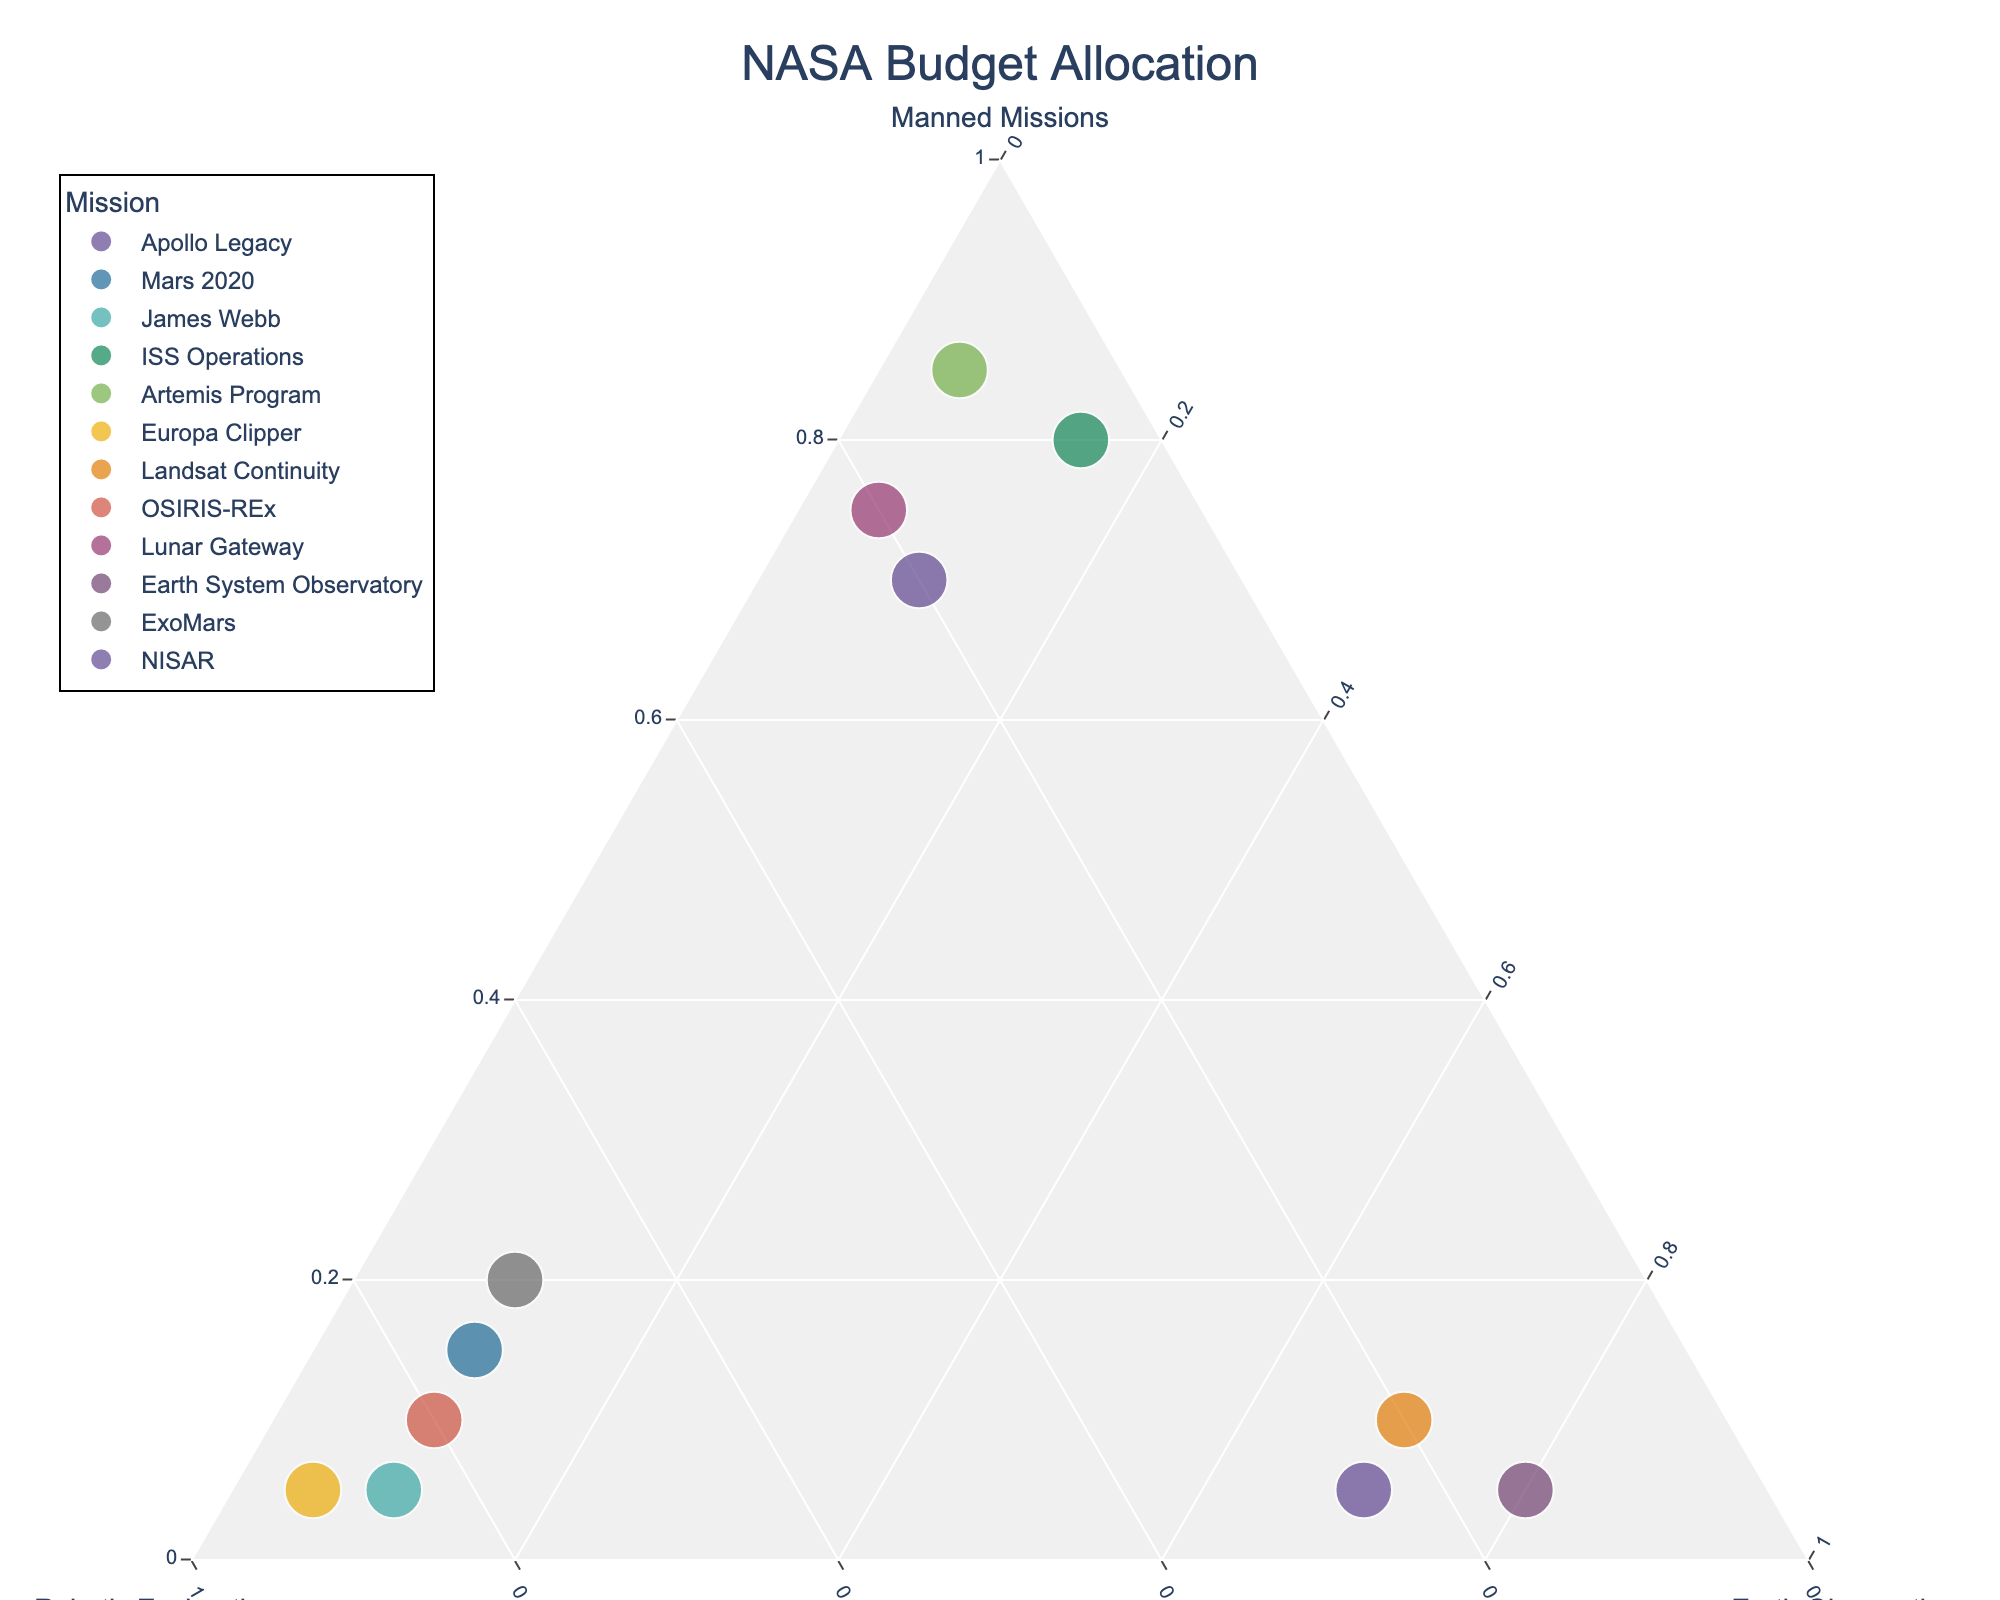What's the title of the plot? The plot title is usually displayed at the top of the figure for identification. Reading it directly gives insights into what the plot represents.
Answer: NASA Budget Allocation How many missions are being plotted? Each point on the ternary plot represents a mission. Counting these points determines the number of missions.
Answer: 12 Which mission has the highest ratio of budget allocated to Manned Missions? Look for the point that is closest to the vertex representing Manned Missions.
Answer: Artemis Program Which missions have a higher budget allocation for Robotic Exploration than Earth Observation and Manned Missions combined? Identify points closer to the Robotic Exploration vertex than to any other vertices and ensure the sum of the other two is less.
Answer: Mars 2020, James Webb, Europa Clipper, OSIRIS-REx, ExoMars What percentage of the Apollo Legacy budget is allocated to Earth Observation? Locate the Apollo Legacy point and identify its coordinates related to Earth Observation along the ternary axis.
Answer: 10% Which mission is closest to having an equal budget allocation among the three categories? Find the point nearest the center of the ternary plot, indicating a balanced budget.
Answer: ExoMars Between ISS Operations and Lunar Gateway, which mission allocates more budget to Earth Observation? Compare the positions on the Earth Observation axis for these two missions.
Answer: ISS Operations How does the budget allocation for the Earth System Observatory compare to that of NISAR? Locate both points and compare their positions on the Earth Observation axis.
Answer: Both allocate 70% to Earth Observation, but NISAR invests more in Robotic Exploration Which mission is the least focused on Manned Missions? Find the point closest to the opposite vertex of Earth's Observation and Robotic Exploration, indicating minimal allocation to Manned Missions.
Answer: Europa Clipper In which missions does the combined budget for Manned Missions and Earth Observation exceed the budget for Robotic Exploration? Identify points where the sum of Manned Missions and Earth Observation percentages is greater than Robotic Exploration percentage.
Answer: Apollo Legacy, ISS Operations, Artemis Program, Lunar Gateway 